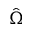<formula> <loc_0><loc_0><loc_500><loc_500>\hat { \Omega }</formula> 